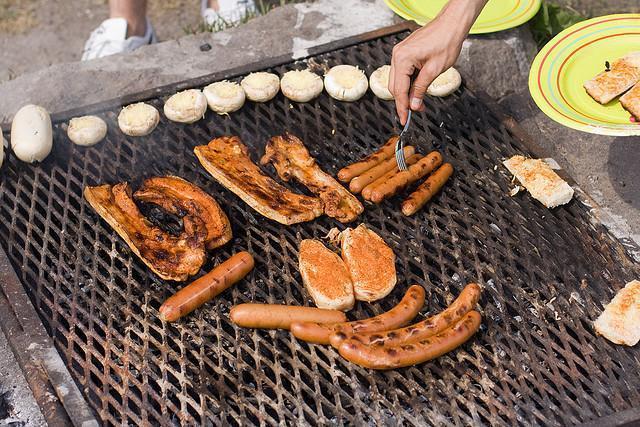How many hot dogs to you see cooking?
Give a very brief answer. 10. How many hot dogs can be seen?
Give a very brief answer. 4. How many people are in the photo?
Give a very brief answer. 2. 